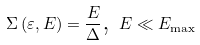Convert formula to latex. <formula><loc_0><loc_0><loc_500><loc_500>\Sigma \left ( \varepsilon , E \right ) = \frac { E } { \Delta } \text {, } E \ll E _ { \max }</formula> 